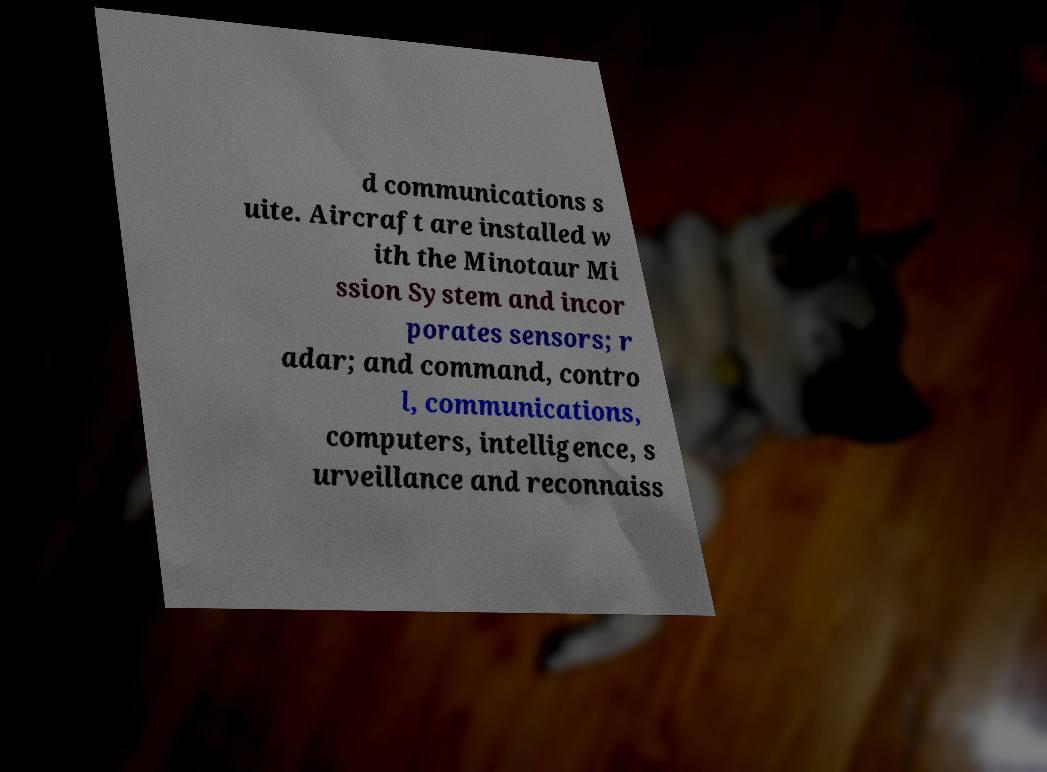I need the written content from this picture converted into text. Can you do that? d communications s uite. Aircraft are installed w ith the Minotaur Mi ssion System and incor porates sensors; r adar; and command, contro l, communications, computers, intelligence, s urveillance and reconnaiss 